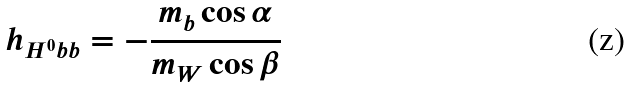<formula> <loc_0><loc_0><loc_500><loc_500>h _ { H ^ { 0 } b b } = - \frac { m _ { b } \cos \alpha } { m _ { W } \cos \beta }</formula> 